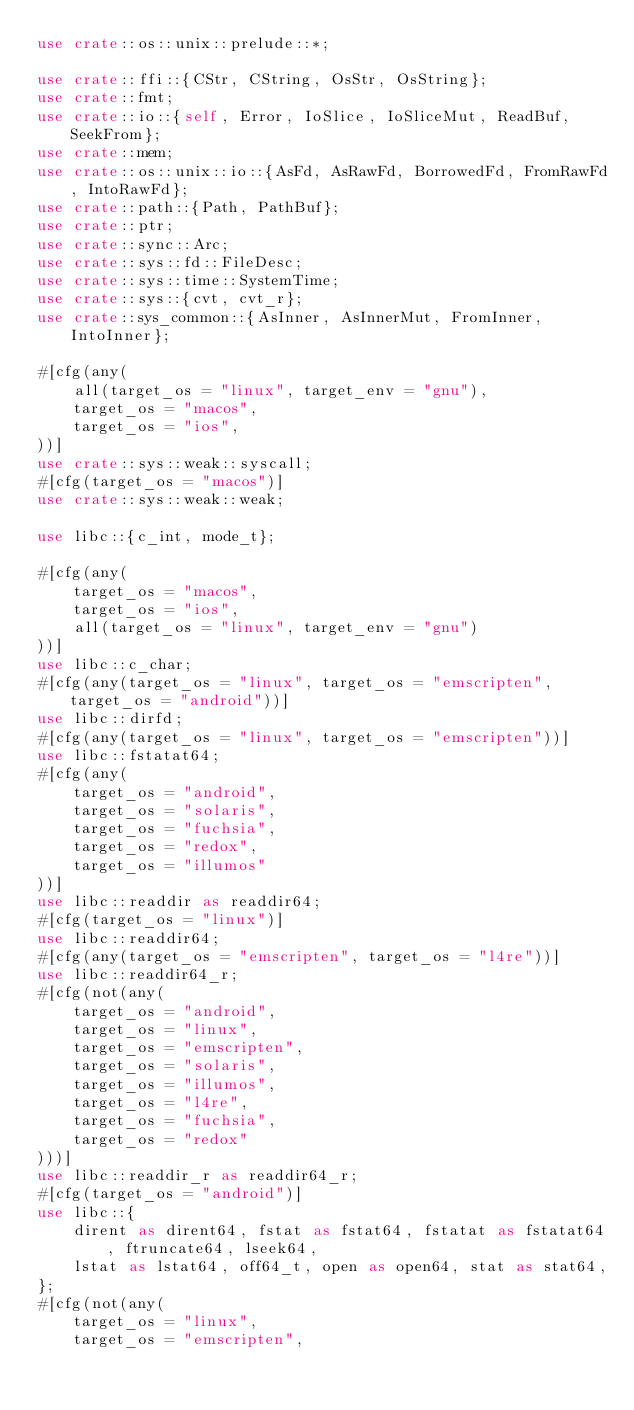Convert code to text. <code><loc_0><loc_0><loc_500><loc_500><_Rust_>use crate::os::unix::prelude::*;

use crate::ffi::{CStr, CString, OsStr, OsString};
use crate::fmt;
use crate::io::{self, Error, IoSlice, IoSliceMut, ReadBuf, SeekFrom};
use crate::mem;
use crate::os::unix::io::{AsFd, AsRawFd, BorrowedFd, FromRawFd, IntoRawFd};
use crate::path::{Path, PathBuf};
use crate::ptr;
use crate::sync::Arc;
use crate::sys::fd::FileDesc;
use crate::sys::time::SystemTime;
use crate::sys::{cvt, cvt_r};
use crate::sys_common::{AsInner, AsInnerMut, FromInner, IntoInner};

#[cfg(any(
    all(target_os = "linux", target_env = "gnu"),
    target_os = "macos",
    target_os = "ios",
))]
use crate::sys::weak::syscall;
#[cfg(target_os = "macos")]
use crate::sys::weak::weak;

use libc::{c_int, mode_t};

#[cfg(any(
    target_os = "macos",
    target_os = "ios",
    all(target_os = "linux", target_env = "gnu")
))]
use libc::c_char;
#[cfg(any(target_os = "linux", target_os = "emscripten", target_os = "android"))]
use libc::dirfd;
#[cfg(any(target_os = "linux", target_os = "emscripten"))]
use libc::fstatat64;
#[cfg(any(
    target_os = "android",
    target_os = "solaris",
    target_os = "fuchsia",
    target_os = "redox",
    target_os = "illumos"
))]
use libc::readdir as readdir64;
#[cfg(target_os = "linux")]
use libc::readdir64;
#[cfg(any(target_os = "emscripten", target_os = "l4re"))]
use libc::readdir64_r;
#[cfg(not(any(
    target_os = "android",
    target_os = "linux",
    target_os = "emscripten",
    target_os = "solaris",
    target_os = "illumos",
    target_os = "l4re",
    target_os = "fuchsia",
    target_os = "redox"
)))]
use libc::readdir_r as readdir64_r;
#[cfg(target_os = "android")]
use libc::{
    dirent as dirent64, fstat as fstat64, fstatat as fstatat64, ftruncate64, lseek64,
    lstat as lstat64, off64_t, open as open64, stat as stat64,
};
#[cfg(not(any(
    target_os = "linux",
    target_os = "emscripten",</code> 